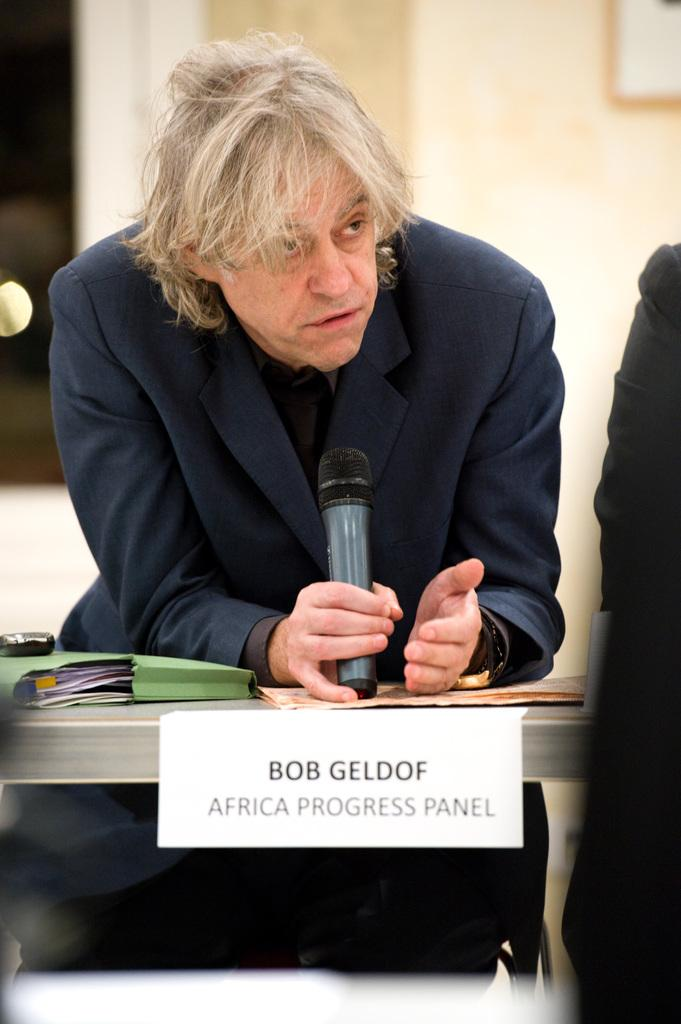What is the man in the image doing? The man is sitting on a chair and speaking on a microphone. What is the man wearing? The man is wearing a suit. What can be seen on the table in the image? There is a file and a name plate on the table. What might the man be using the microphone for? The man might be using the microphone for a presentation or speech. What type of game is the scarecrow playing with the man in the image? There is no scarecrow present in the image, and therefore no game can be observed. 